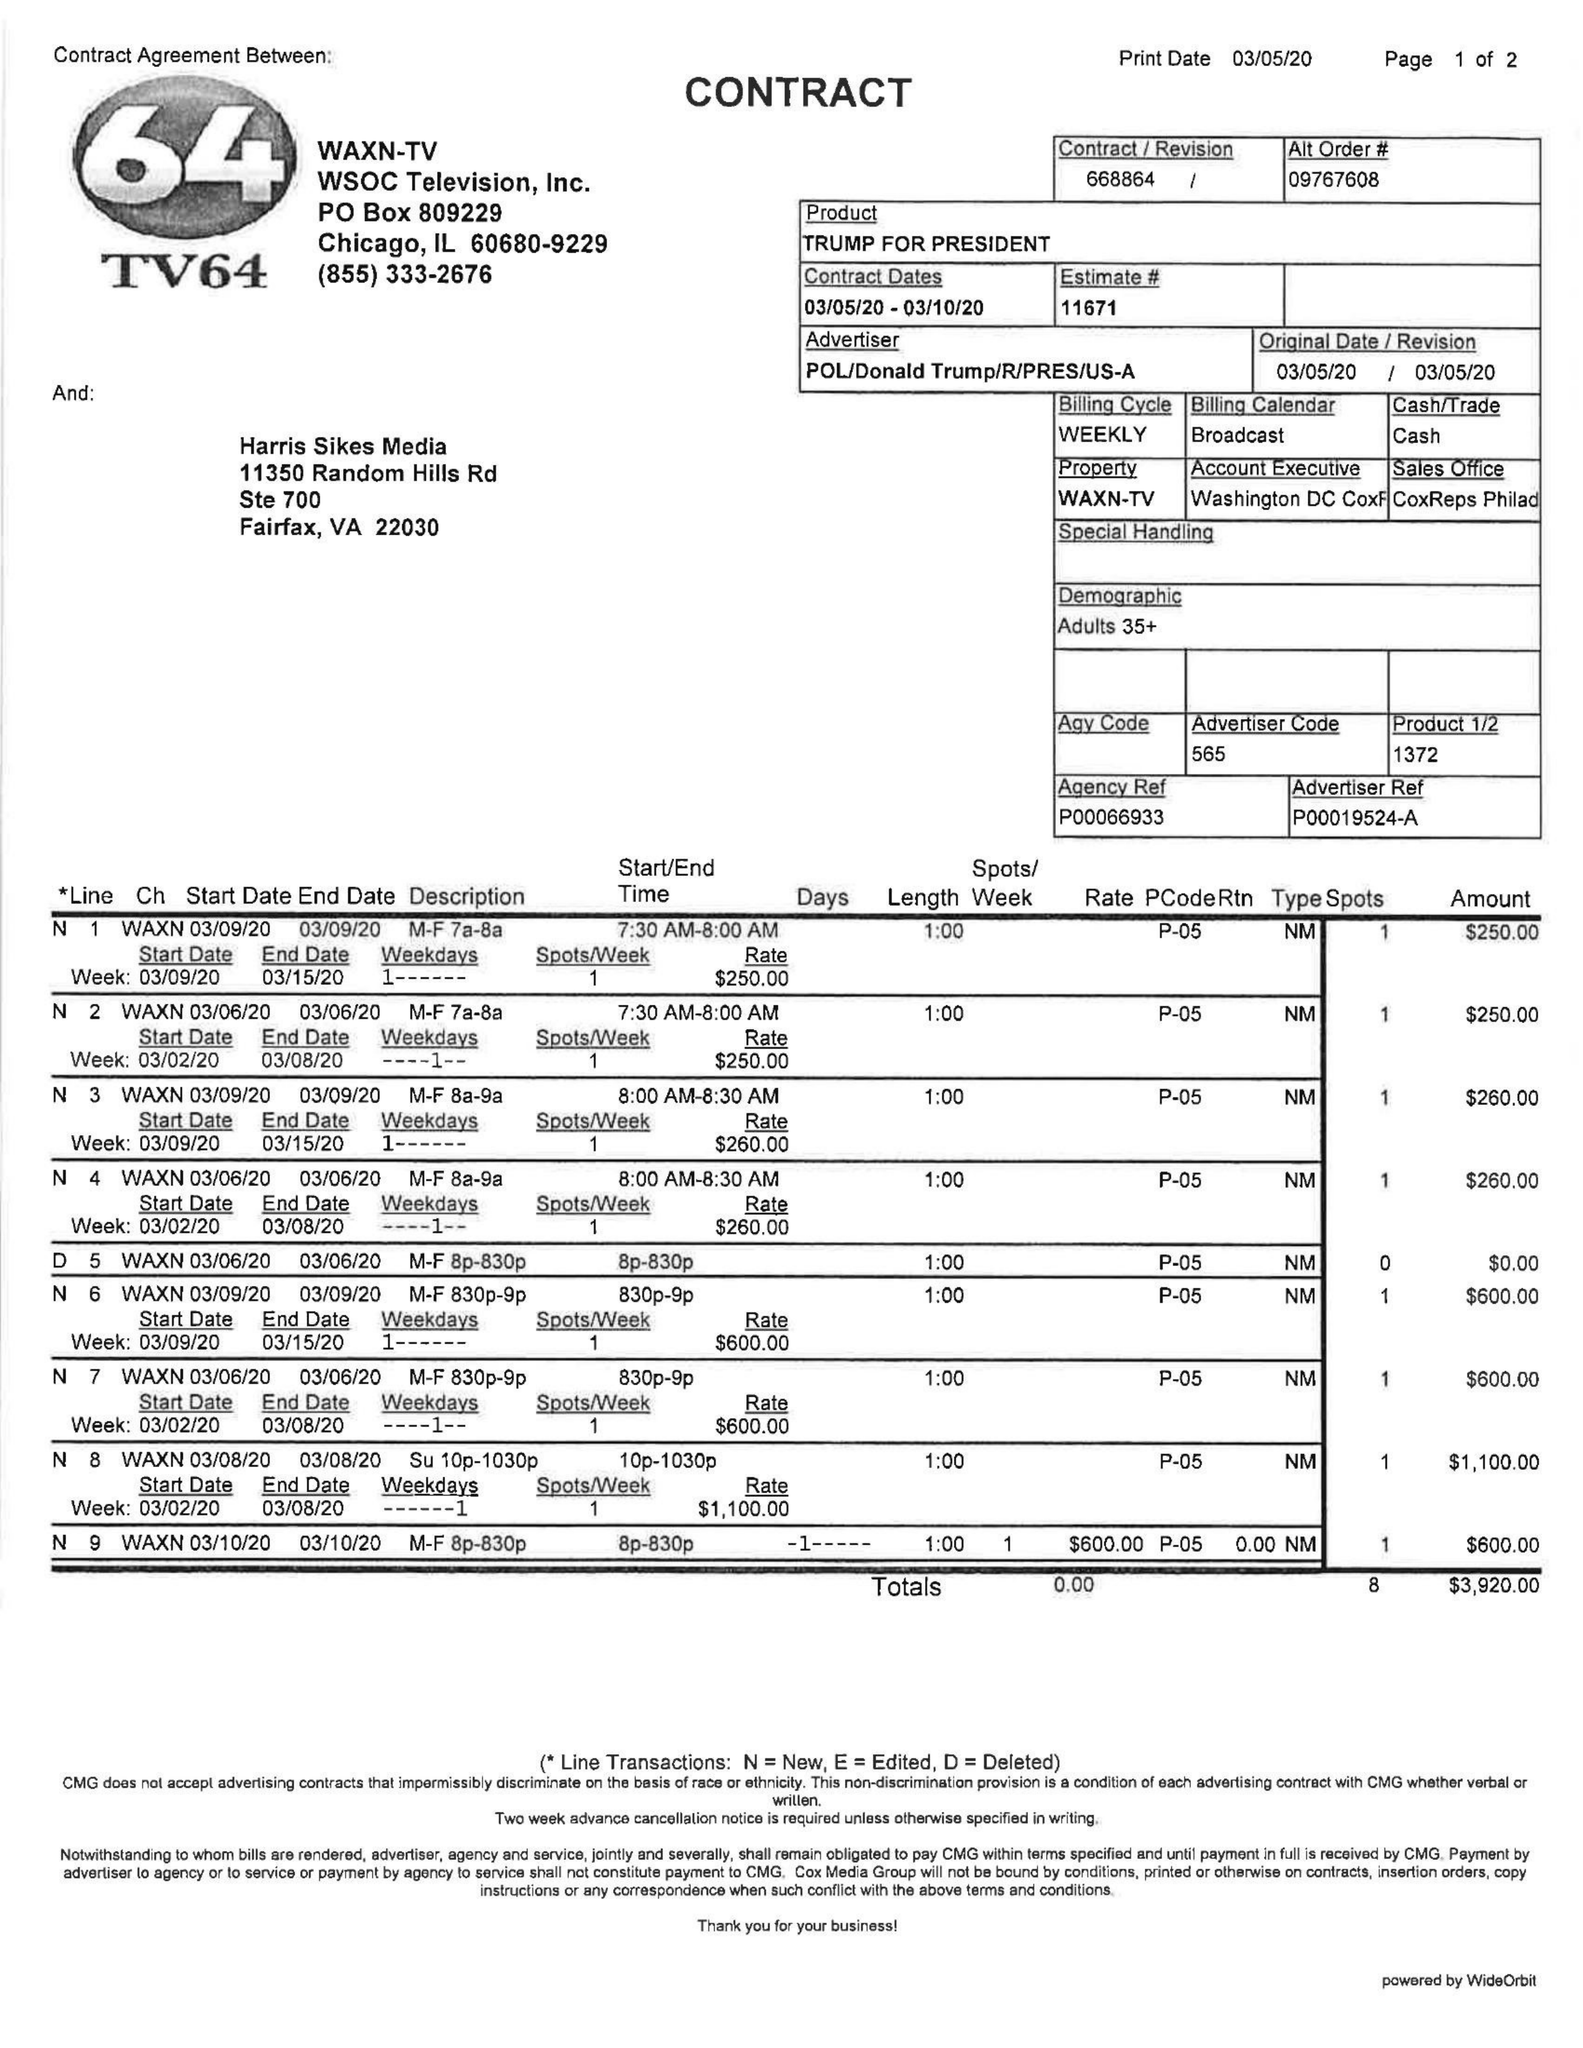What is the value for the gross_amount?
Answer the question using a single word or phrase. 3920.00 